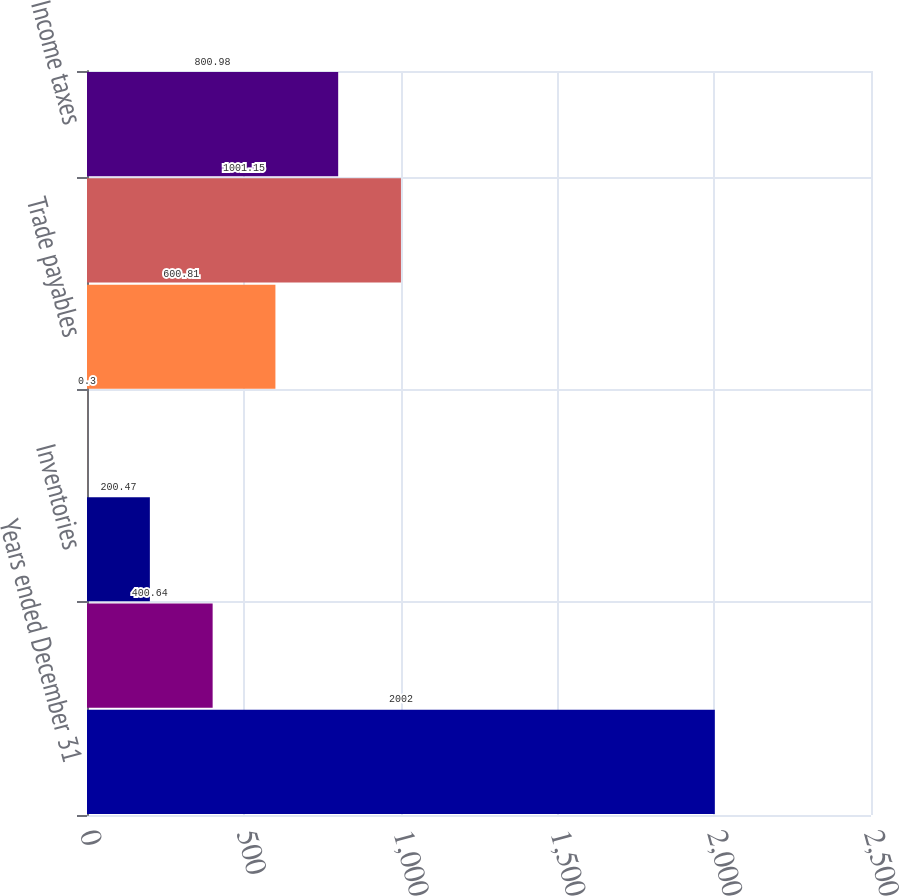Convert chart to OTSL. <chart><loc_0><loc_0><loc_500><loc_500><bar_chart><fcel>Years ended December 31<fcel>Receivables<fcel>Inventories<fcel>Other current assets<fcel>Trade payables<fcel>Accrued liabilities including<fcel>Income taxes<nl><fcel>2002<fcel>400.64<fcel>200.47<fcel>0.3<fcel>600.81<fcel>1001.15<fcel>800.98<nl></chart> 